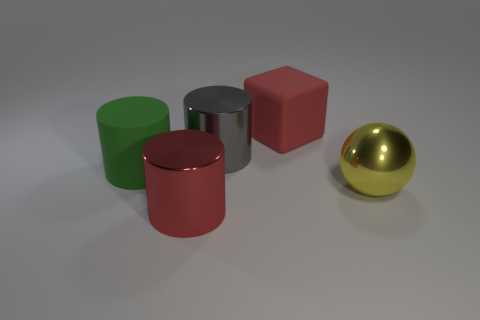Subtract all green rubber cylinders. How many cylinders are left? 2 Subtract all gray cylinders. How many cylinders are left? 2 Subtract all blocks. How many objects are left? 4 Subtract 1 balls. How many balls are left? 0 Subtract all green blocks. How many green cylinders are left? 1 Add 3 big yellow metal spheres. How many objects exist? 8 Subtract 1 green cylinders. How many objects are left? 4 Subtract all cyan cylinders. Subtract all brown spheres. How many cylinders are left? 3 Subtract all cyan matte blocks. Subtract all yellow metallic balls. How many objects are left? 4 Add 1 red cylinders. How many red cylinders are left? 2 